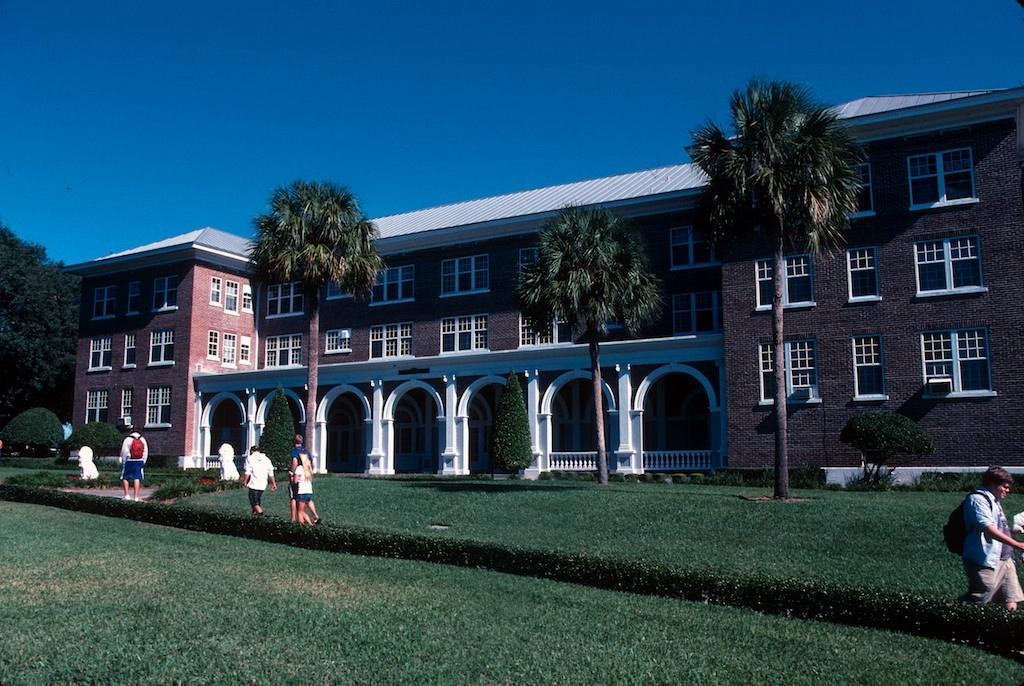What type of structure can be seen in the image? There is a building in the image. What architectural features are present in the image? There are walls, windows, pillars, and railings visible in the image. What type of vegetation is present in the image? There are trees and plants in the image. Are there any people in the image? Yes, there are people in the image. What type of surface can be seen in the image? There is a walkway and grass in the image. What is visible at the top of the image? The sky is visible at the top of the image. What type of creature is seen interacting with the wax in the image? There is no creature or wax present in the image. Can you describe the stranger in the image? There is no stranger mentioned in the provided facts, and the image does not depict any unknown individuals. 